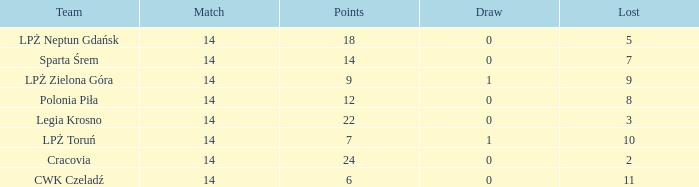What is the lowest points for a match before 14? None. 